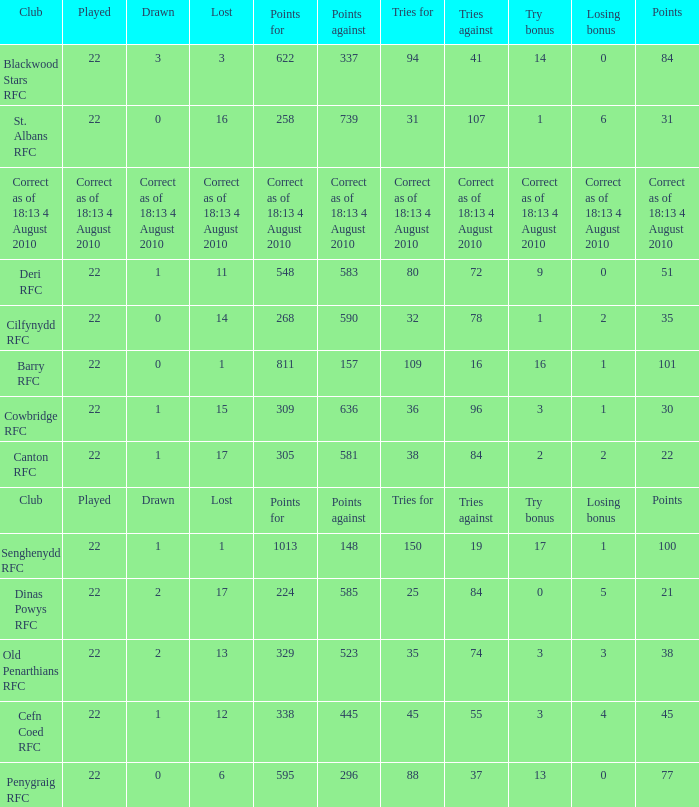What is the points when the lost was 11? 548.0. 